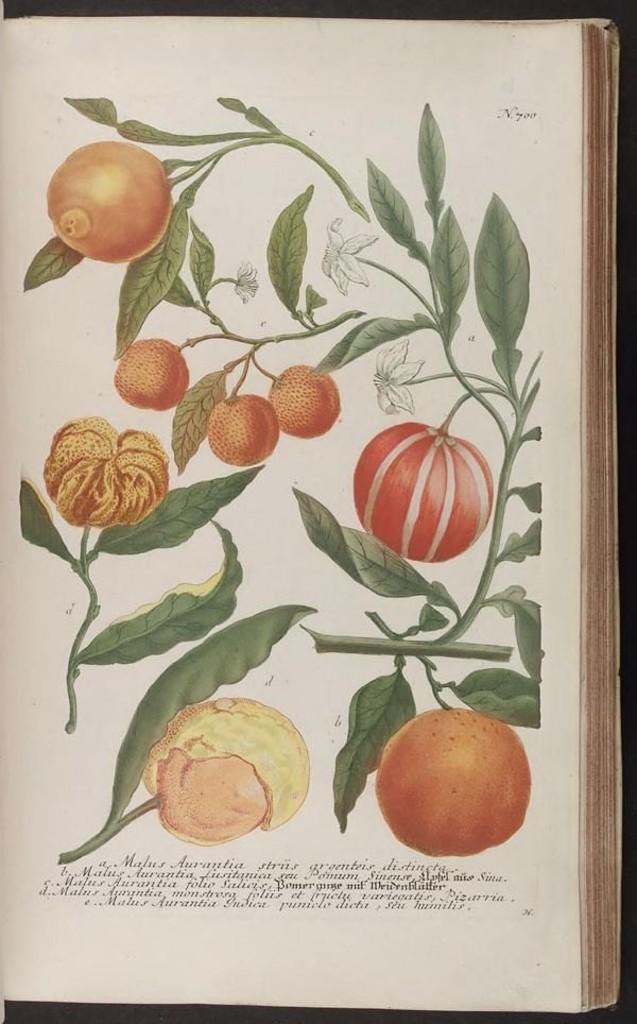How would you summarize this image in a sentence or two? Here there is a plant with the fruit, this is a book. 